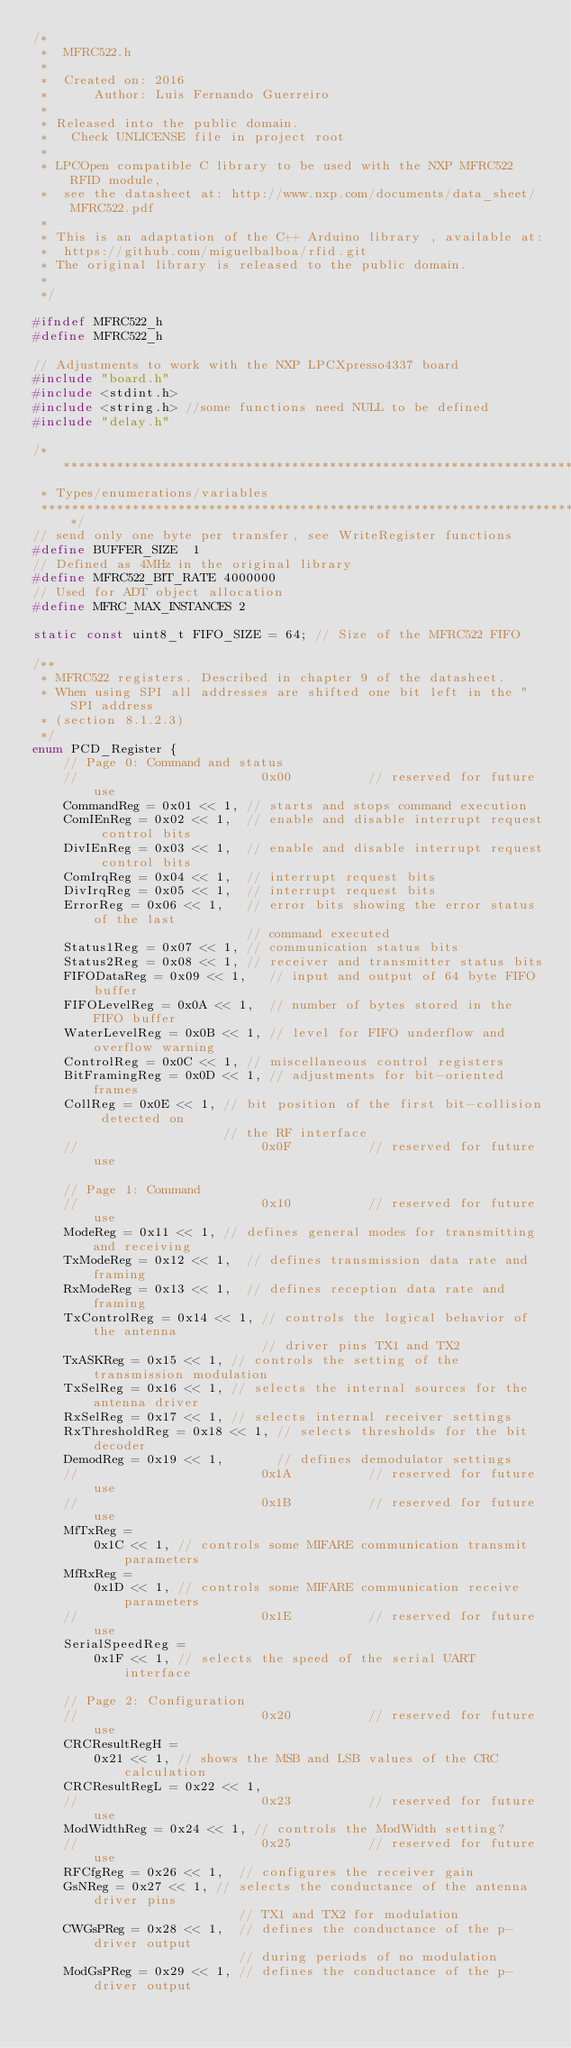<code> <loc_0><loc_0><loc_500><loc_500><_C_>/*   
 *	MFRC522.h
 *
 *  Created on: 2016
 *      Author: Luis Fernando Guerreiro
 *
 * Released into the public domain. 
 *   Check UNLICENSE file in project root 
 *	 
 * LPCOpen compatible C library to be used with the NXP MFRC522 RFID module,
 *  see the datasheet at: http://www.nxp.com/documents/data_sheet/MFRC522.pdf
 *  
 * This is an adaptation of the C++ Arduino library , available at:
 * 	https://github.com/miguelbalboa/rfid.git
 * The original library is released to the public domain.
 *
 */

#ifndef MFRC522_h
#define MFRC522_h

// Adjustments to work with the NXP LPCXpresso4337 board
#include "board.h"
#include <stdint.h>
#include <string.h> //some functions need NULL to be defined
#include "delay.h"

/*******************************************************************************
 * Types/enumerations/variables
 ******************************************************************************/
// send only one byte per transfer, see WriteRegister functions
#define BUFFER_SIZE  1 
// Defined as 4MHz in the original library
#define MFRC522_BIT_RATE 4000000 
// Used for ADT object allocation
#define MFRC_MAX_INSTANCES 2	 

static const uint8_t FIFO_SIZE = 64; // Size of the MFRC522 FIFO

/**
 * MFRC522 registers. Described in chapter 9 of the datasheet.
 * When using SPI all addresses are shifted one bit left in the "SPI address
 * (section 8.1.2.3)
 */
enum PCD_Register {
	// Page 0: Command and status
	//						  0x00			// reserved for future use
	CommandReg = 0x01 << 1, // starts and stops command execution
	ComIEnReg = 0x02 << 1,  // enable and disable interrupt request control bits
	DivIEnReg = 0x03 << 1,  // enable and disable interrupt request control bits
	ComIrqReg = 0x04 << 1,  // interrupt request bits
	DivIrqReg = 0x05 << 1,  // interrupt request bits
	ErrorReg = 0x06 << 1,   // error bits showing the error status of the last
							// command executed
	Status1Reg = 0x07 << 1, // communication status bits
	Status2Reg = 0x08 << 1, // receiver and transmitter status bits
	FIFODataReg = 0x09 << 1,   // input and output of 64 byte FIFO buffer
	FIFOLevelReg = 0x0A << 1,  // number of bytes stored in the FIFO buffer
	WaterLevelReg = 0x0B << 1, // level for FIFO underflow and overflow warning
	ControlReg = 0x0C << 1,	// miscellaneous control registers
	BitFramingReg = 0x0D << 1, // adjustments for bit-oriented frames
	CollReg = 0x0E << 1, // bit position of the first bit-collision detected on
						 // the RF interface
	//						  0x0F			// reserved for future use

	// Page 1: Command
	// 						  0x10			// reserved for future use
	ModeReg = 0x11 << 1, // defines general modes for transmitting and receiving
	TxModeReg = 0x12 << 1,	// defines transmission data rate and framing
	RxModeReg = 0x13 << 1,	// defines reception data rate and framing
	TxControlReg = 0x14 << 1, // controls the logical behavior of the antenna
							  // driver pins TX1 and TX2
	TxASKReg = 0x15 << 1, // controls the setting of the transmission modulation
	TxSelReg = 0x16 << 1, // selects the internal sources for the antenna driver
	RxSelReg = 0x17 << 1, // selects internal receiver settings
	RxThresholdReg = 0x18 << 1, // selects thresholds for the bit decoder
	DemodReg = 0x19 << 1,		// defines demodulator settings
	// 						  0x1A			// reserved for future use
	// 						  0x1B			// reserved for future use
	MfTxReg =
		0x1C << 1, // controls some MIFARE communication transmit parameters
	MfRxReg =
		0x1D << 1, // controls some MIFARE communication receive parameters
	// 						  0x1E			// reserved for future use
	SerialSpeedReg =
		0x1F << 1, // selects the speed of the serial UART interface

	// Page 2: Configuration
	// 						  0x20			// reserved for future use
	CRCResultRegH =
		0x21 << 1, // shows the MSB and LSB values of the CRC calculation
	CRCResultRegL = 0x22 << 1,
	// 						  0x23			// reserved for future use
	ModWidthReg = 0x24 << 1, // controls the ModWidth setting?
	// 						  0x25			// reserved for future use
	RFCfgReg = 0x26 << 1,  // configures the receiver gain
	GsNReg = 0x27 << 1,	// selects the conductance of the antenna driver pins
						   // TX1 and TX2 for modulation
	CWGsPReg = 0x28 << 1,  // defines the conductance of the p-driver output
						   // during periods of no modulation
	ModGsPReg = 0x29 << 1, // defines the conductance of the p-driver output</code> 